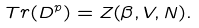Convert formula to latex. <formula><loc_0><loc_0><loc_500><loc_500>T r ( D ^ { p } ) = Z ( \beta , V , N ) .</formula> 